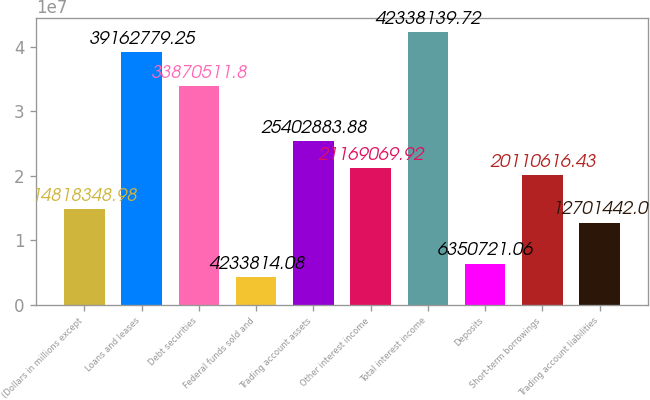Convert chart to OTSL. <chart><loc_0><loc_0><loc_500><loc_500><bar_chart><fcel>(Dollars in millions except<fcel>Loans and leases<fcel>Debt securities<fcel>Federal funds sold and<fcel>Trading account assets<fcel>Other interest income<fcel>Total interest income<fcel>Deposits<fcel>Short-term borrowings<fcel>Trading account liabilities<nl><fcel>1.48183e+07<fcel>3.91628e+07<fcel>3.38705e+07<fcel>4.23381e+06<fcel>2.54029e+07<fcel>2.11691e+07<fcel>4.23381e+07<fcel>6.35072e+06<fcel>2.01106e+07<fcel>1.27014e+07<nl></chart> 